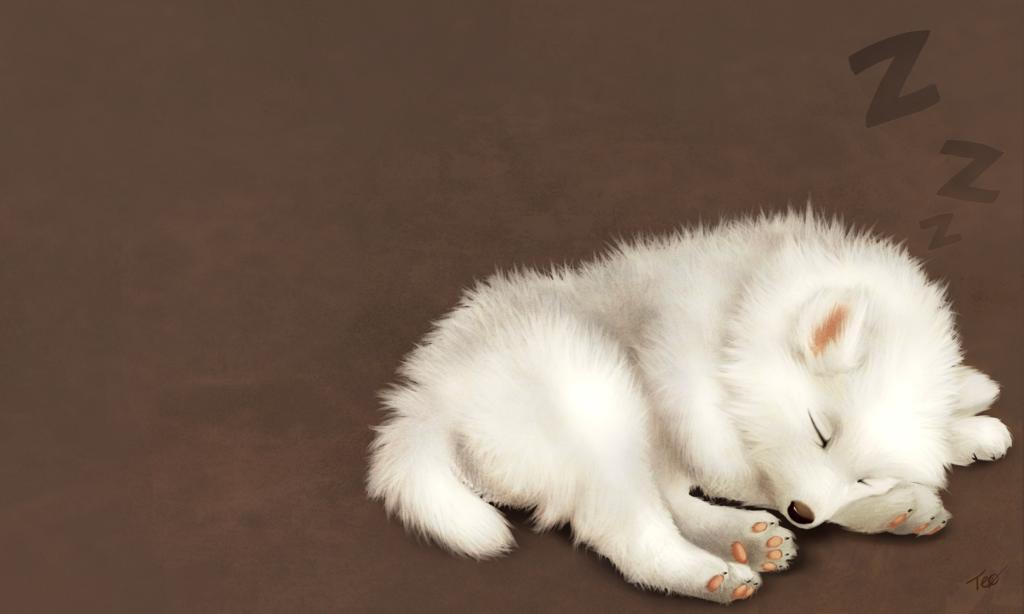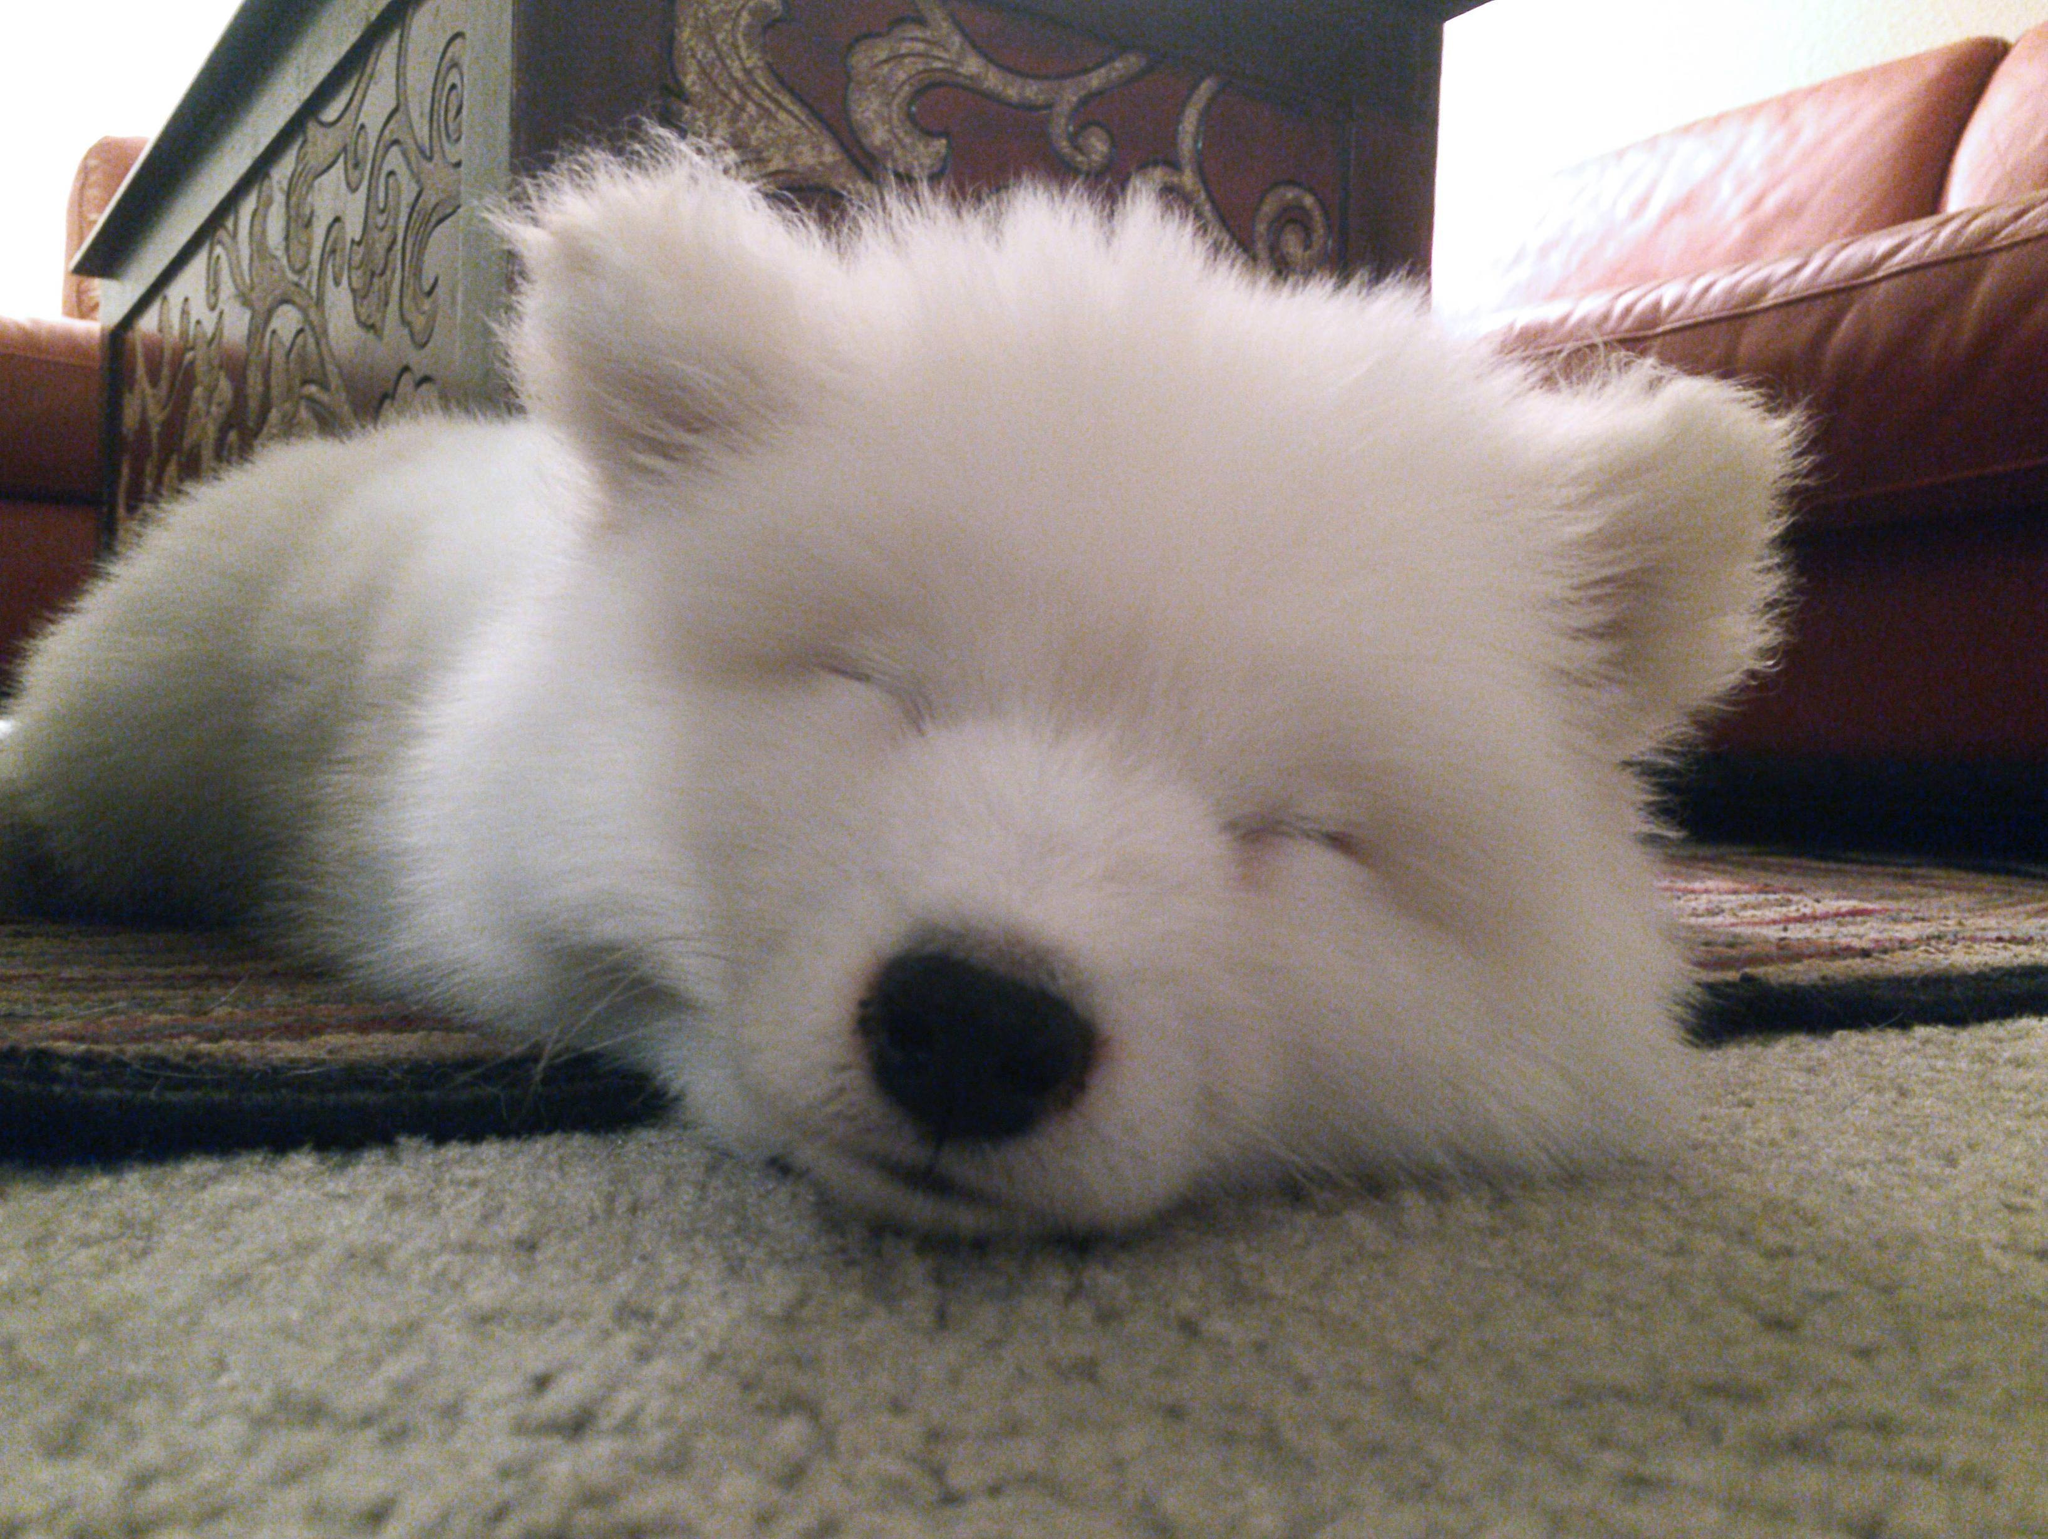The first image is the image on the left, the second image is the image on the right. Given the left and right images, does the statement "One image shows a white dog sleeping on a hard tile floor." hold true? Answer yes or no. No. The first image is the image on the left, the second image is the image on the right. Examine the images to the left and right. Is the description "The dog in one of the images is sleeping on a wooden surface." accurate? Answer yes or no. No. 